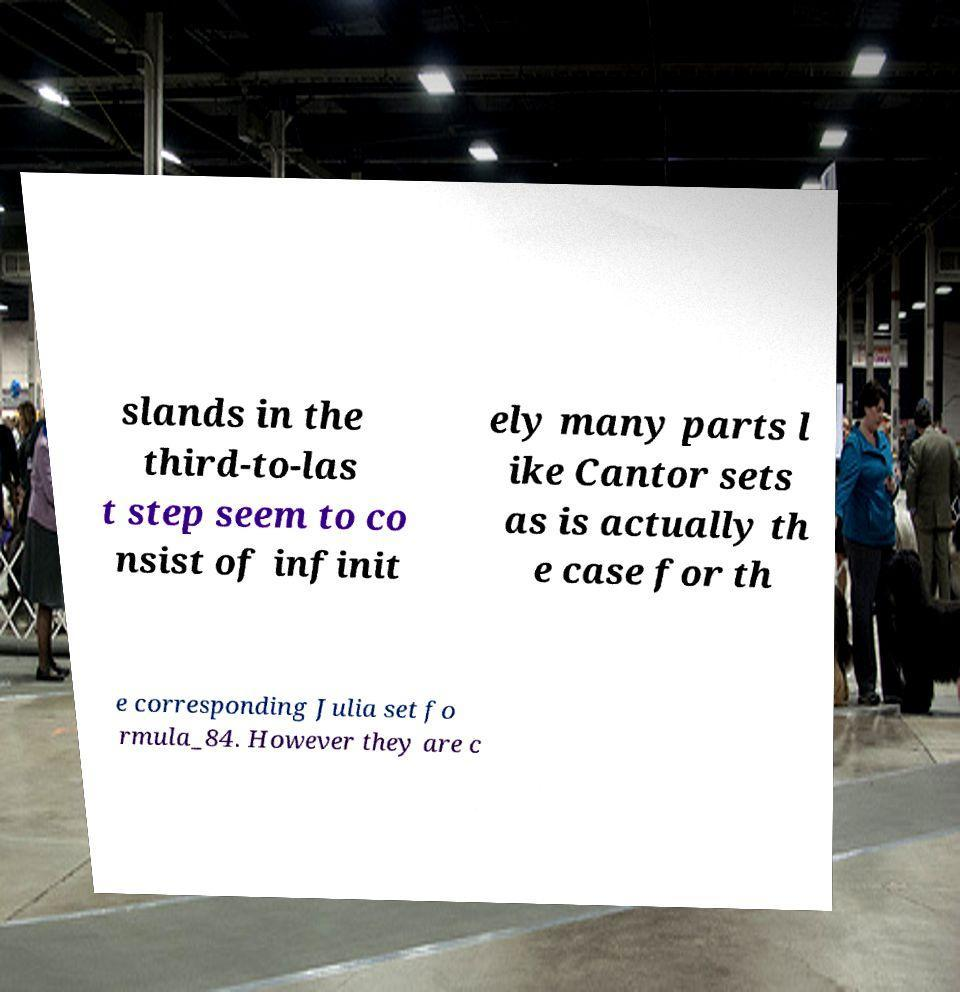What messages or text are displayed in this image? I need them in a readable, typed format. slands in the third-to-las t step seem to co nsist of infinit ely many parts l ike Cantor sets as is actually th e case for th e corresponding Julia set fo rmula_84. However they are c 